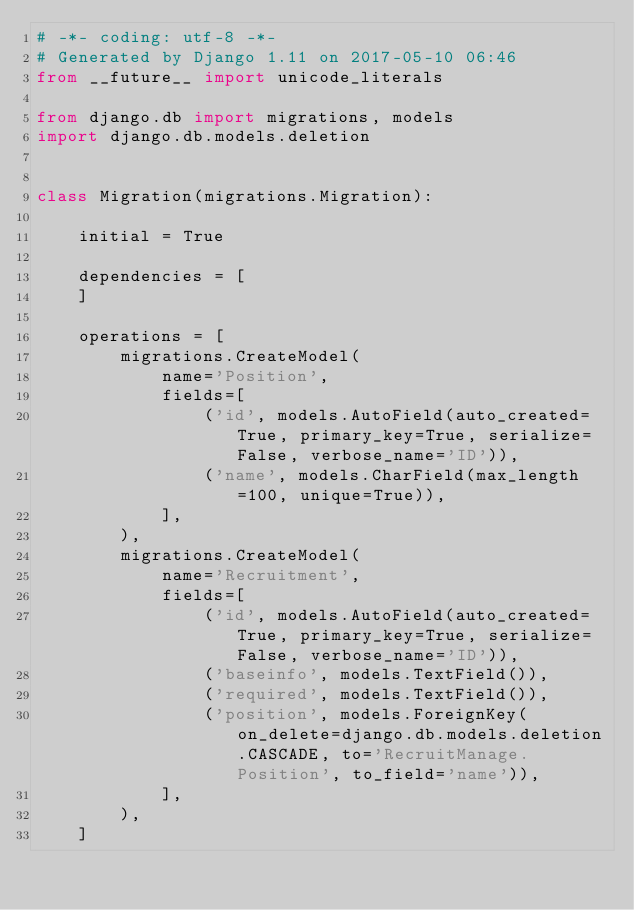Convert code to text. <code><loc_0><loc_0><loc_500><loc_500><_Python_># -*- coding: utf-8 -*-
# Generated by Django 1.11 on 2017-05-10 06:46
from __future__ import unicode_literals

from django.db import migrations, models
import django.db.models.deletion


class Migration(migrations.Migration):

    initial = True

    dependencies = [
    ]

    operations = [
        migrations.CreateModel(
            name='Position',
            fields=[
                ('id', models.AutoField(auto_created=True, primary_key=True, serialize=False, verbose_name='ID')),
                ('name', models.CharField(max_length=100, unique=True)),
            ],
        ),
        migrations.CreateModel(
            name='Recruitment',
            fields=[
                ('id', models.AutoField(auto_created=True, primary_key=True, serialize=False, verbose_name='ID')),
                ('baseinfo', models.TextField()),
                ('required', models.TextField()),
                ('position', models.ForeignKey(on_delete=django.db.models.deletion.CASCADE, to='RecruitManage.Position', to_field='name')),
            ],
        ),
    ]
</code> 